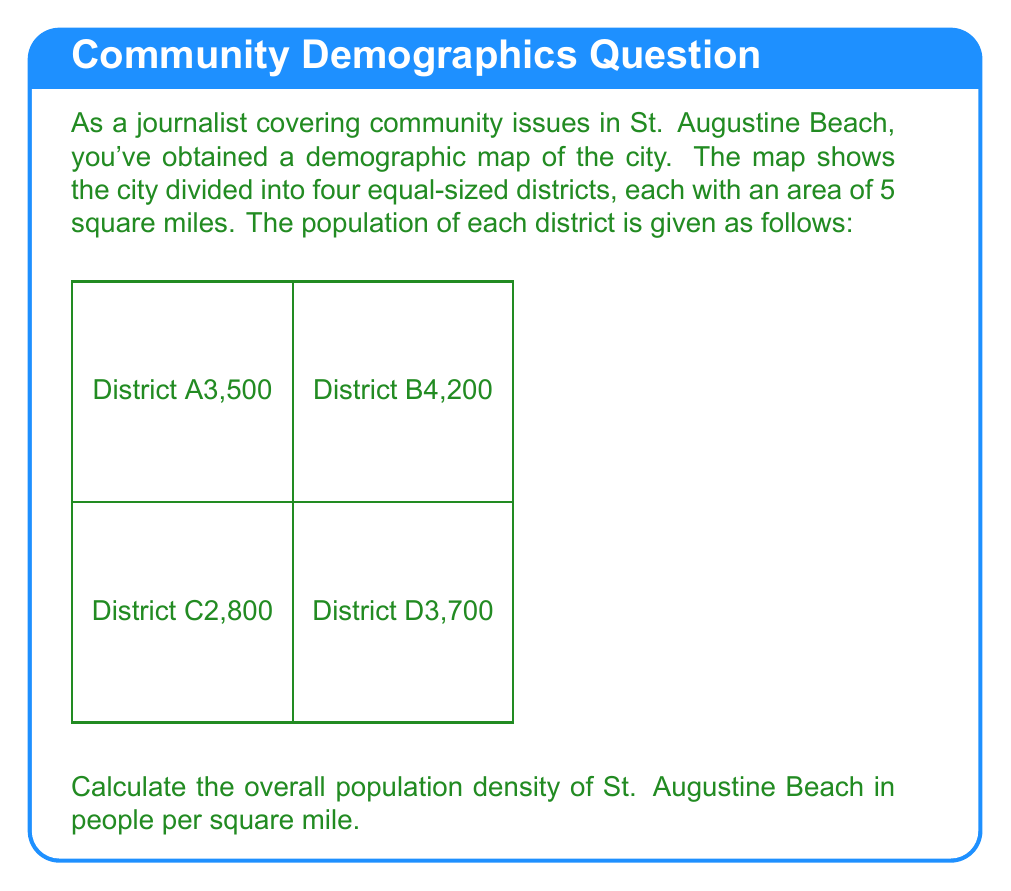Provide a solution to this math problem. To calculate the overall population density, we need to follow these steps:

1. Calculate the total population:
   District A: 3,500
   District B: 4,200
   District C: 2,800
   District D: 3,700
   
   Total population = $3,500 + 4,200 + 2,800 + 3,700 = 14,200$ people

2. Calculate the total area:
   Each district is 5 square miles
   Total area = $5 \times 4 = 20$ square miles

3. Calculate the population density:
   Population density is defined as population divided by area.
   
   $\text{Population Density} = \frac{\text{Total Population}}{\text{Total Area}}$

   $\text{Population Density} = \frac{14,200 \text{ people}}{20 \text{ square miles}}$

   $\text{Population Density} = 710 \text{ people per square mile}$

Therefore, the overall population density of St. Augustine Beach is 710 people per square mile.
Answer: 710 people/sq mi 